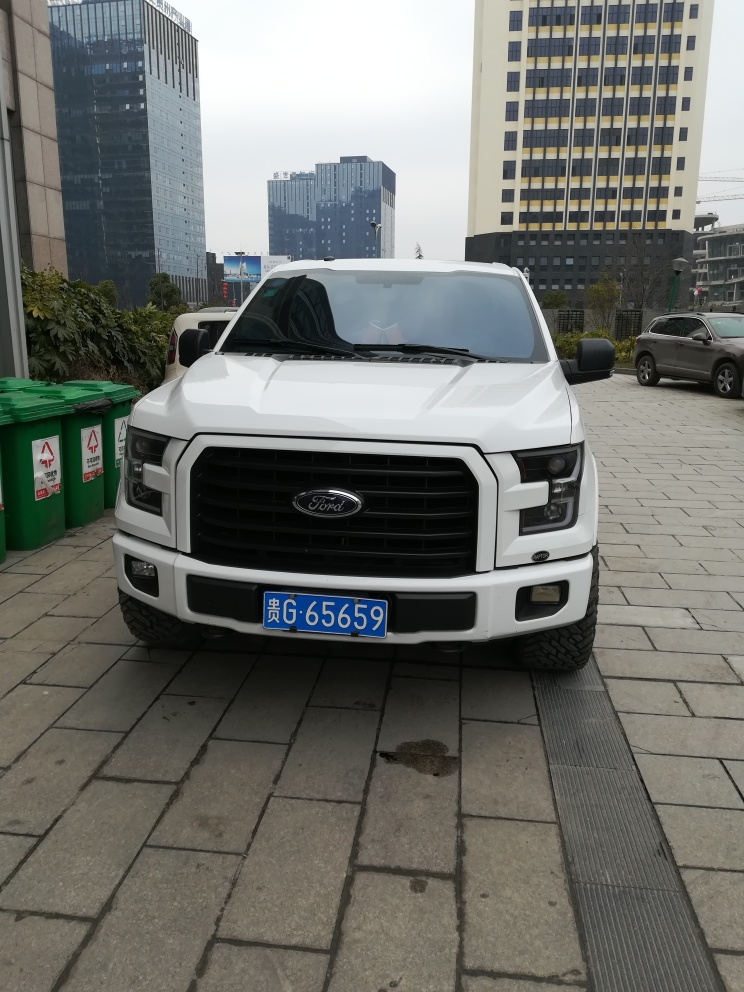Could you describe the vehicle in the image? Certainly! The vehicle is a white pickup truck with a large front grill bearing the Ford logo. It appears to be a modern, well-maintained vehicle, likely designed for both utility and comfort. What might be the model of the truck? Based on the visual design and features, it resembles a Ford F-150, a popular model known for its robustness and capabilities as a full-size pickup truck. 